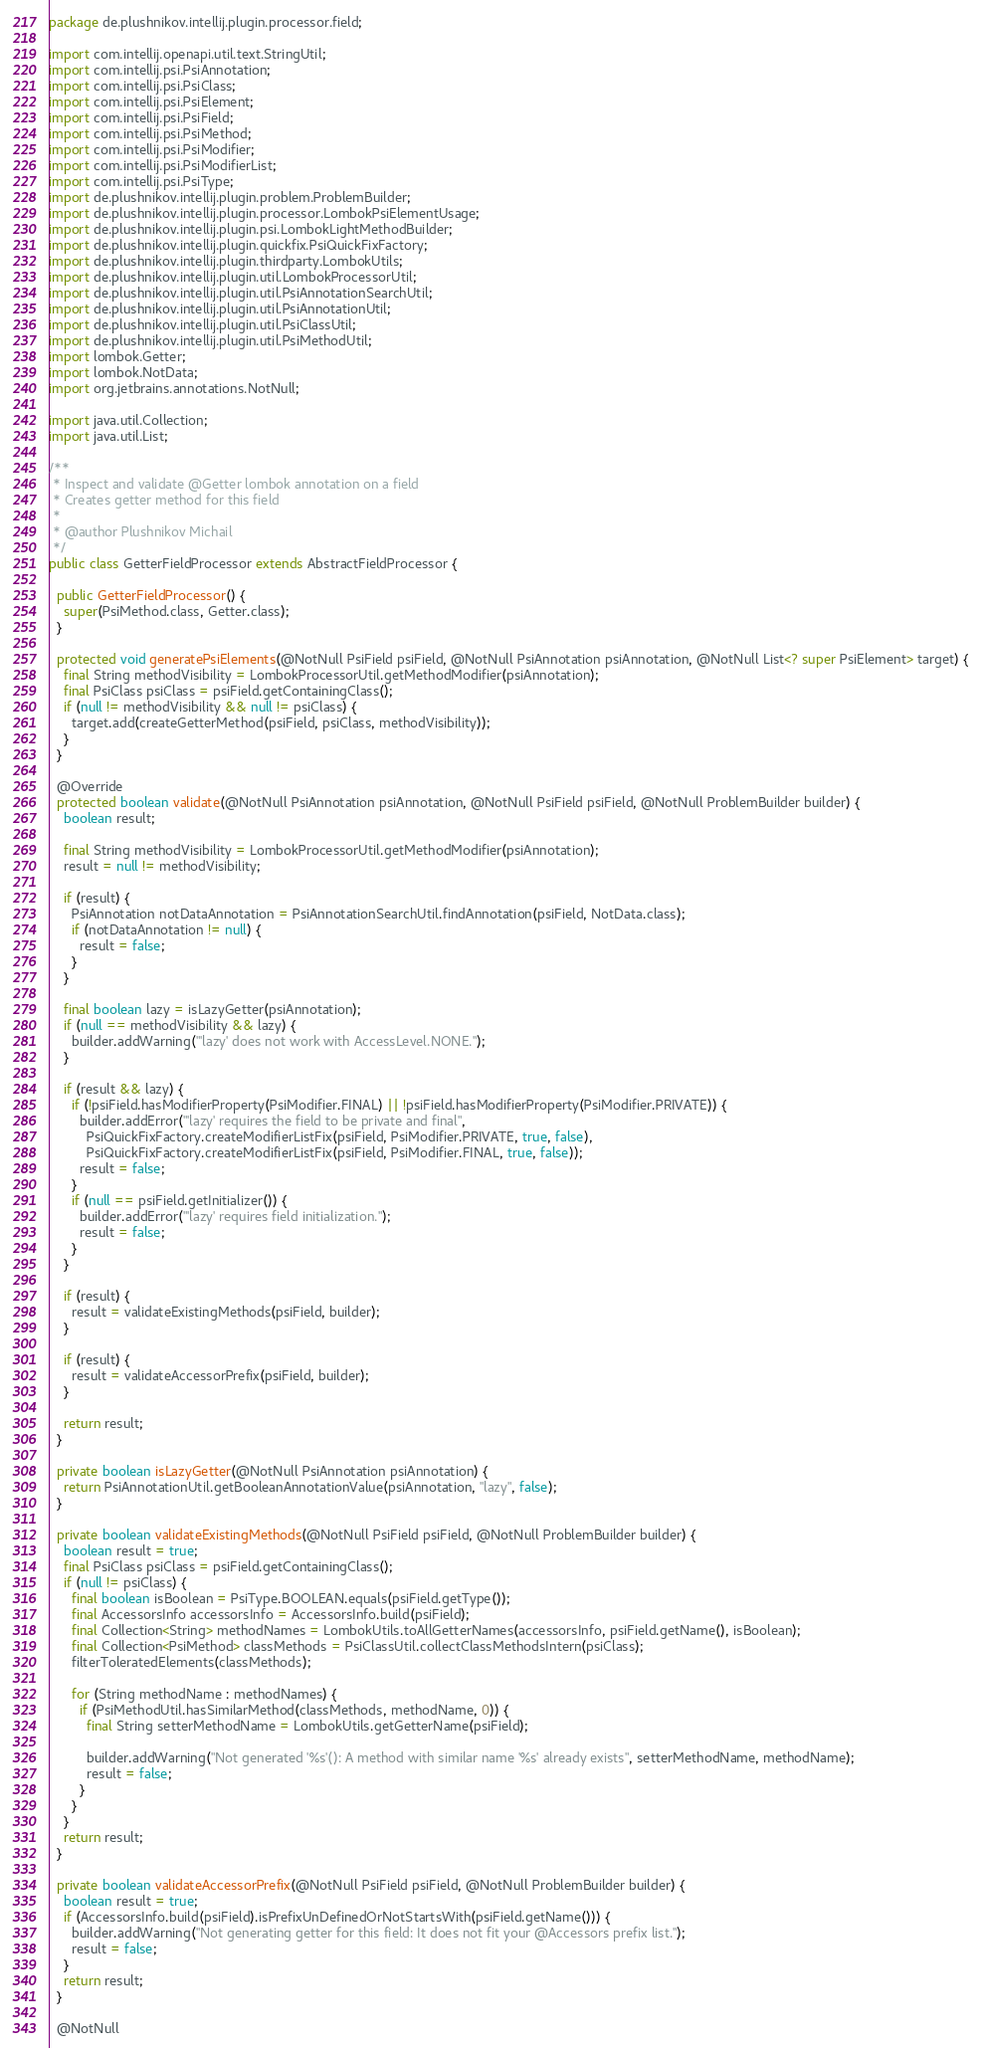Convert code to text. <code><loc_0><loc_0><loc_500><loc_500><_Java_>package de.plushnikov.intellij.plugin.processor.field;

import com.intellij.openapi.util.text.StringUtil;
import com.intellij.psi.PsiAnnotation;
import com.intellij.psi.PsiClass;
import com.intellij.psi.PsiElement;
import com.intellij.psi.PsiField;
import com.intellij.psi.PsiMethod;
import com.intellij.psi.PsiModifier;
import com.intellij.psi.PsiModifierList;
import com.intellij.psi.PsiType;
import de.plushnikov.intellij.plugin.problem.ProblemBuilder;
import de.plushnikov.intellij.plugin.processor.LombokPsiElementUsage;
import de.plushnikov.intellij.plugin.psi.LombokLightMethodBuilder;
import de.plushnikov.intellij.plugin.quickfix.PsiQuickFixFactory;
import de.plushnikov.intellij.plugin.thirdparty.LombokUtils;
import de.plushnikov.intellij.plugin.util.LombokProcessorUtil;
import de.plushnikov.intellij.plugin.util.PsiAnnotationSearchUtil;
import de.plushnikov.intellij.plugin.util.PsiAnnotationUtil;
import de.plushnikov.intellij.plugin.util.PsiClassUtil;
import de.plushnikov.intellij.plugin.util.PsiMethodUtil;
import lombok.Getter;
import lombok.NotData;
import org.jetbrains.annotations.NotNull;

import java.util.Collection;
import java.util.List;

/**
 * Inspect and validate @Getter lombok annotation on a field
 * Creates getter method for this field
 *
 * @author Plushnikov Michail
 */
public class GetterFieldProcessor extends AbstractFieldProcessor {

  public GetterFieldProcessor() {
    super(PsiMethod.class, Getter.class);
  }

  protected void generatePsiElements(@NotNull PsiField psiField, @NotNull PsiAnnotation psiAnnotation, @NotNull List<? super PsiElement> target) {
    final String methodVisibility = LombokProcessorUtil.getMethodModifier(psiAnnotation);
    final PsiClass psiClass = psiField.getContainingClass();
    if (null != methodVisibility && null != psiClass) {
      target.add(createGetterMethod(psiField, psiClass, methodVisibility));
    }
  }

  @Override
  protected boolean validate(@NotNull PsiAnnotation psiAnnotation, @NotNull PsiField psiField, @NotNull ProblemBuilder builder) {
    boolean result;

    final String methodVisibility = LombokProcessorUtil.getMethodModifier(psiAnnotation);
    result = null != methodVisibility;

    if (result) {
      PsiAnnotation notDataAnnotation = PsiAnnotationSearchUtil.findAnnotation(psiField, NotData.class);
      if (notDataAnnotation != null) {
        result = false;
      }
    }

    final boolean lazy = isLazyGetter(psiAnnotation);
    if (null == methodVisibility && lazy) {
      builder.addWarning("'lazy' does not work with AccessLevel.NONE.");
    }

    if (result && lazy) {
      if (!psiField.hasModifierProperty(PsiModifier.FINAL) || !psiField.hasModifierProperty(PsiModifier.PRIVATE)) {
        builder.addError("'lazy' requires the field to be private and final",
          PsiQuickFixFactory.createModifierListFix(psiField, PsiModifier.PRIVATE, true, false),
          PsiQuickFixFactory.createModifierListFix(psiField, PsiModifier.FINAL, true, false));
        result = false;
      }
      if (null == psiField.getInitializer()) {
        builder.addError("'lazy' requires field initialization.");
        result = false;
      }
    }

    if (result) {
      result = validateExistingMethods(psiField, builder);
    }

    if (result) {
      result = validateAccessorPrefix(psiField, builder);
    }

    return result;
  }

  private boolean isLazyGetter(@NotNull PsiAnnotation psiAnnotation) {
    return PsiAnnotationUtil.getBooleanAnnotationValue(psiAnnotation, "lazy", false);
  }

  private boolean validateExistingMethods(@NotNull PsiField psiField, @NotNull ProblemBuilder builder) {
    boolean result = true;
    final PsiClass psiClass = psiField.getContainingClass();
    if (null != psiClass) {
      final boolean isBoolean = PsiType.BOOLEAN.equals(psiField.getType());
      final AccessorsInfo accessorsInfo = AccessorsInfo.build(psiField);
      final Collection<String> methodNames = LombokUtils.toAllGetterNames(accessorsInfo, psiField.getName(), isBoolean);
      final Collection<PsiMethod> classMethods = PsiClassUtil.collectClassMethodsIntern(psiClass);
      filterToleratedElements(classMethods);

      for (String methodName : methodNames) {
        if (PsiMethodUtil.hasSimilarMethod(classMethods, methodName, 0)) {
          final String setterMethodName = LombokUtils.getGetterName(psiField);

          builder.addWarning("Not generated '%s'(): A method with similar name '%s' already exists", setterMethodName, methodName);
          result = false;
        }
      }
    }
    return result;
  }

  private boolean validateAccessorPrefix(@NotNull PsiField psiField, @NotNull ProblemBuilder builder) {
    boolean result = true;
    if (AccessorsInfo.build(psiField).isPrefixUnDefinedOrNotStartsWith(psiField.getName())) {
      builder.addWarning("Not generating getter for this field: It does not fit your @Accessors prefix list.");
      result = false;
    }
    return result;
  }

  @NotNull</code> 